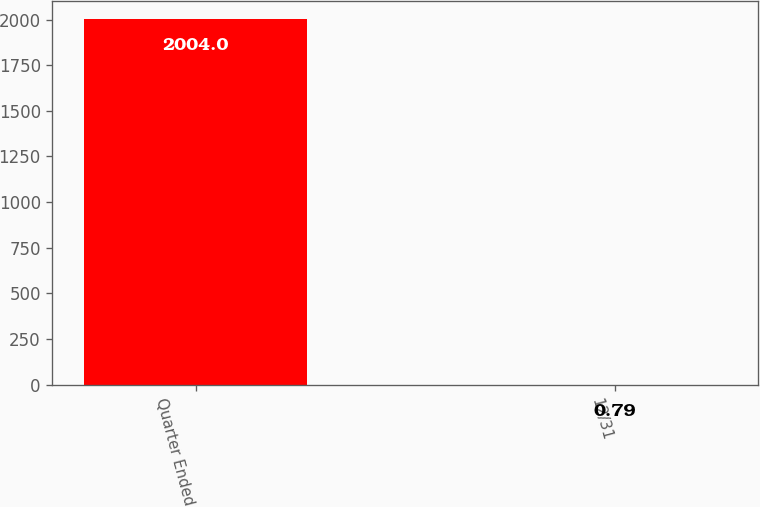Convert chart to OTSL. <chart><loc_0><loc_0><loc_500><loc_500><bar_chart><fcel>Quarter Ended<fcel>12/31<nl><fcel>2004<fcel>0.79<nl></chart> 